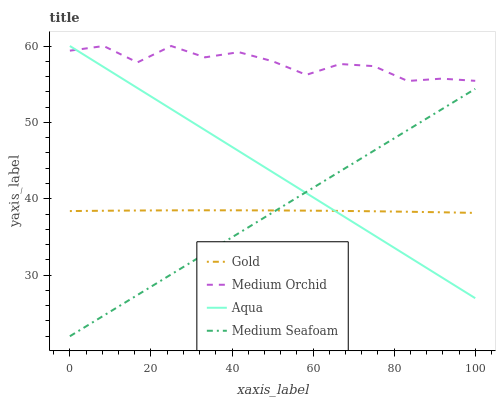Does Medium Seafoam have the minimum area under the curve?
Answer yes or no. Yes. Does Aqua have the minimum area under the curve?
Answer yes or no. No. Does Aqua have the maximum area under the curve?
Answer yes or no. No. Is Medium Orchid the roughest?
Answer yes or no. Yes. Is Aqua the smoothest?
Answer yes or no. No. Is Aqua the roughest?
Answer yes or no. No. Does Aqua have the lowest value?
Answer yes or no. No. Does Medium Seafoam have the highest value?
Answer yes or no. No. Is Medium Seafoam less than Medium Orchid?
Answer yes or no. Yes. Is Medium Orchid greater than Medium Seafoam?
Answer yes or no. Yes. Does Medium Seafoam intersect Medium Orchid?
Answer yes or no. No. 